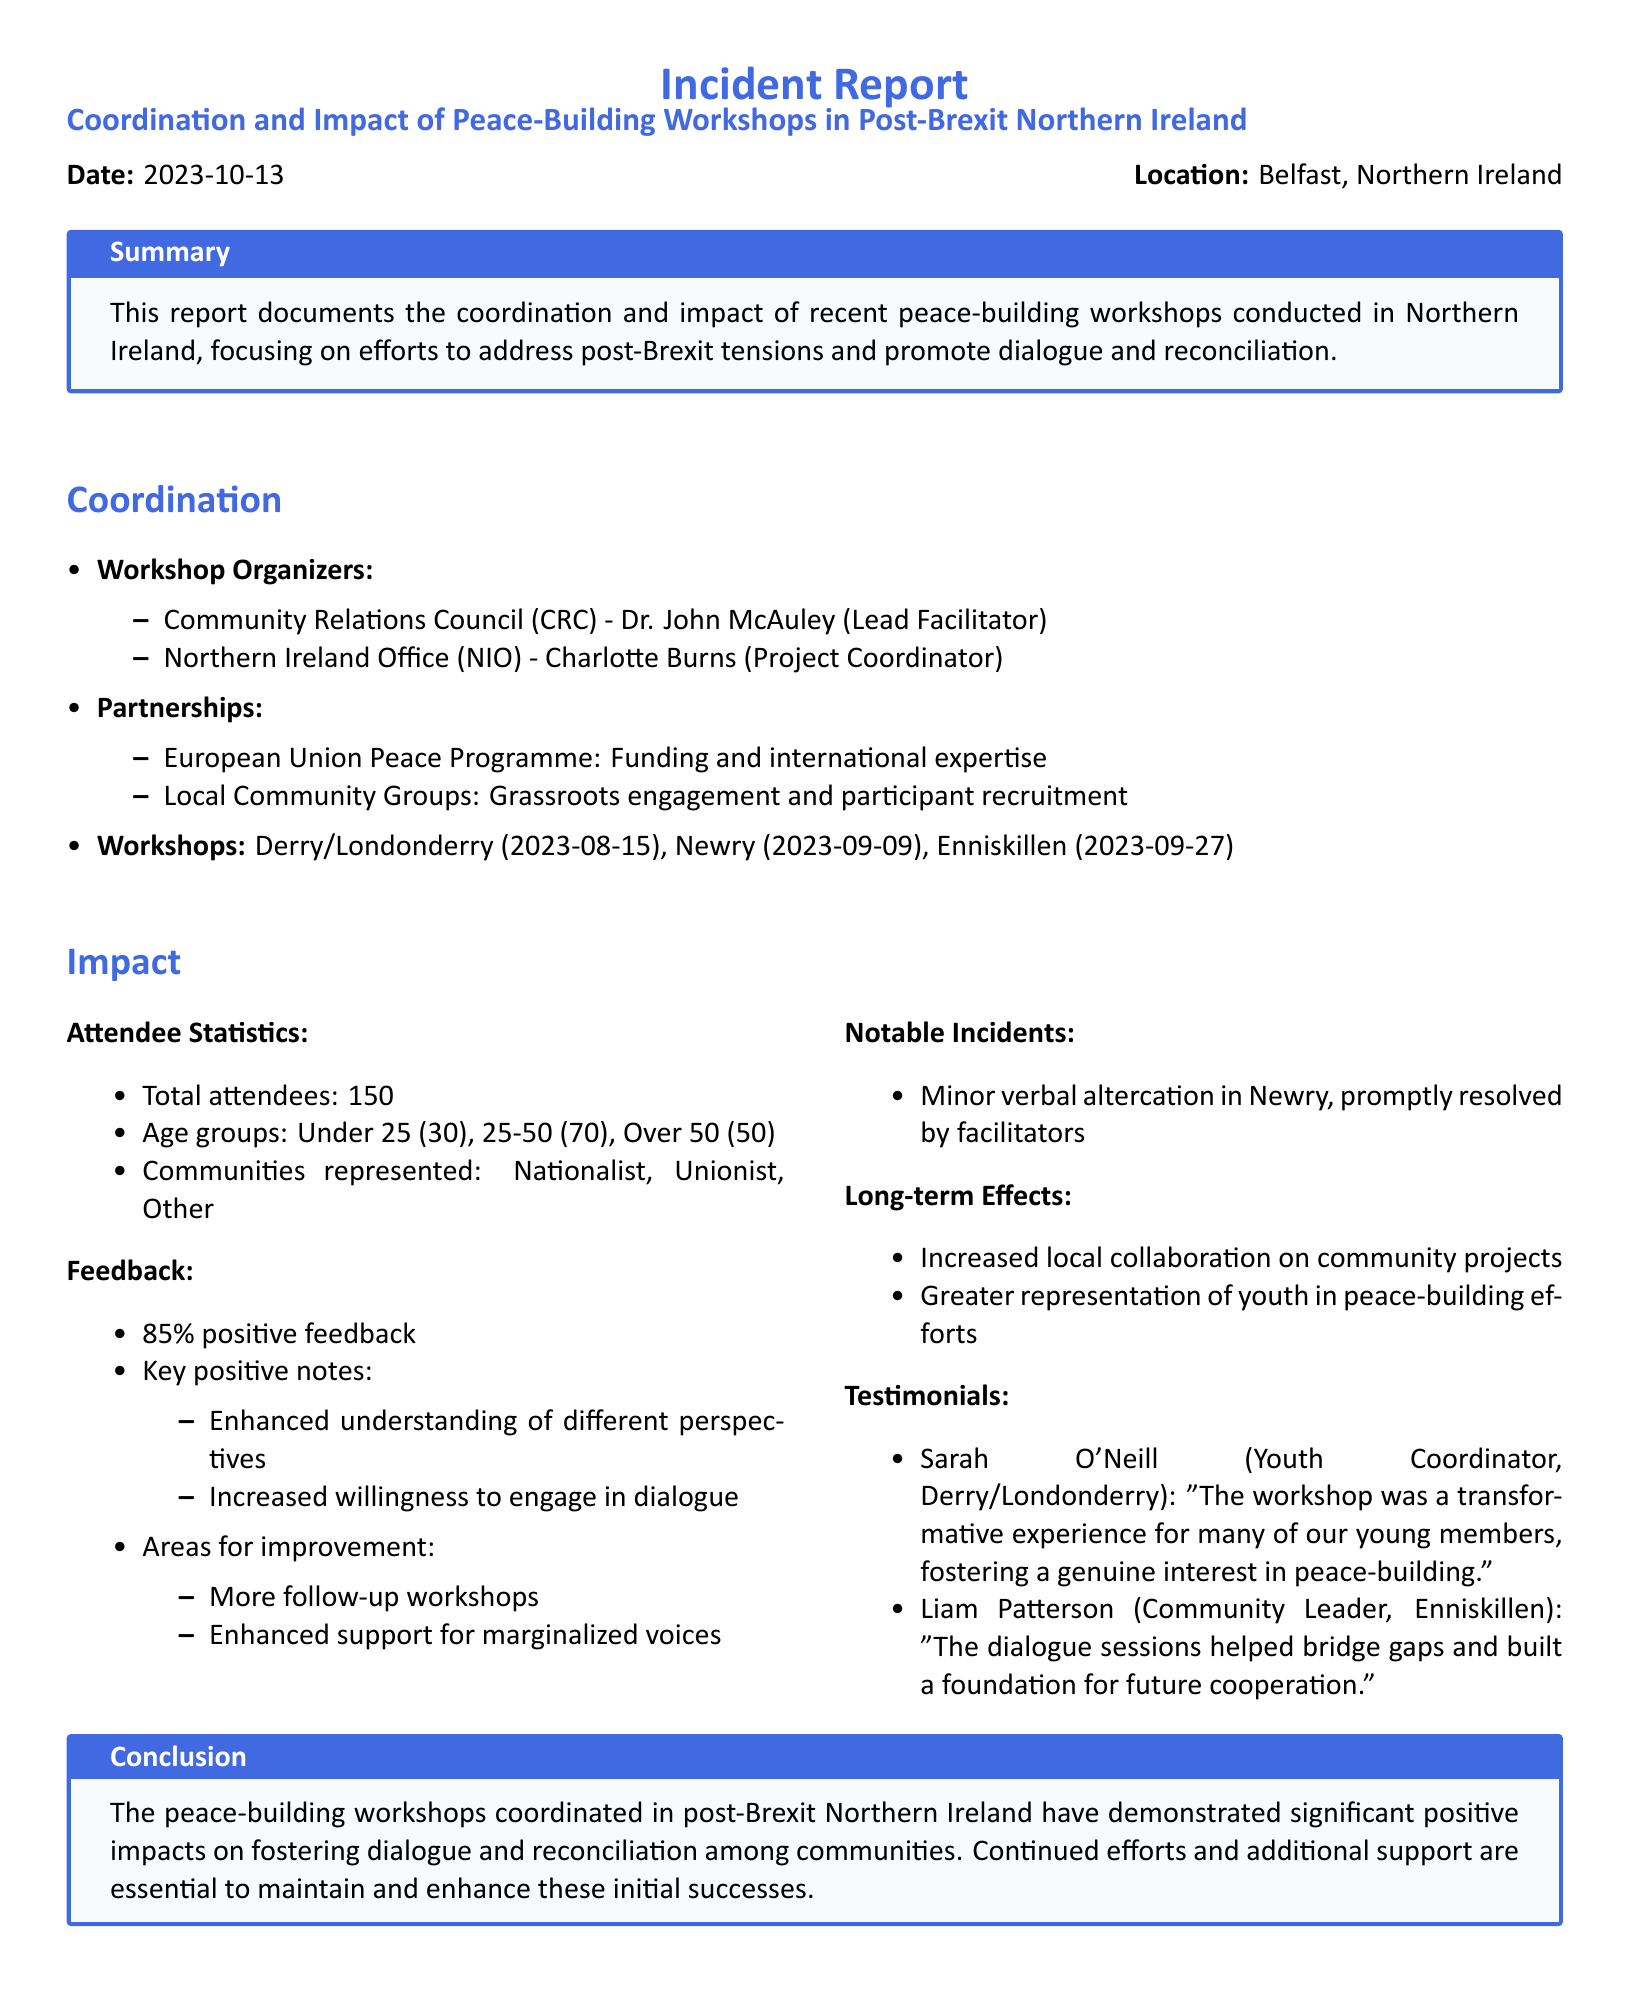What is the date of the report? The date of the report is listed at the beginning of the document.
Answer: 2023-10-13 Who is the Lead Facilitator? The Lead Facilitator is mentioned under the workshop organizers section of the document.
Answer: Dr. John McAuley What percentage of attendees provided positive feedback? The feedback section specifies the percentage of positive responses given by attendees.
Answer: 85% How many workshops were conducted? The number of workshops is noted in the coordination section of the report.
Answer: Three What is one area for improvement mentioned in the feedback? The feedback section lists areas for improvement suggested by attendees.
Answer: More follow-up workshops What notable incident occurred in Newry? The report mentions specific incidents during the workshops and their resolutions.
Answer: Minor verbal altercation What is one long-term effect of the workshops? The long-term effects are detailed in the impact section of the document.
Answer: Increased local collaboration on community projects Who is quoted in a testimonial regarding the transformative experience of the workshop? The testimonials section includes quotes from participants who found the workshops impactful.
Answer: Sarah O'Neill 